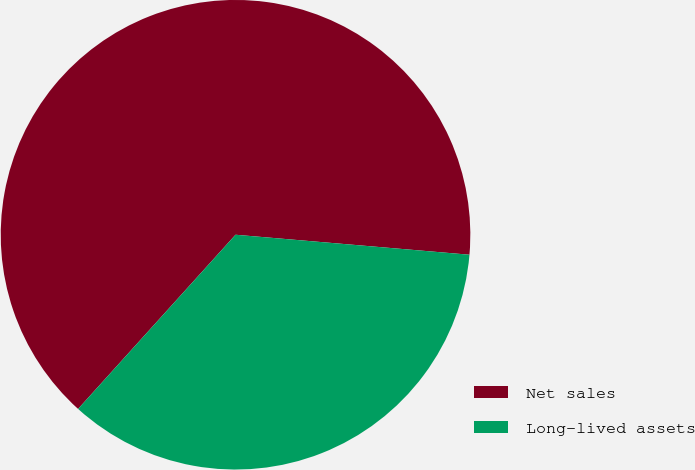Convert chart. <chart><loc_0><loc_0><loc_500><loc_500><pie_chart><fcel>Net sales<fcel>Long-lived assets<nl><fcel>64.66%<fcel>35.34%<nl></chart> 